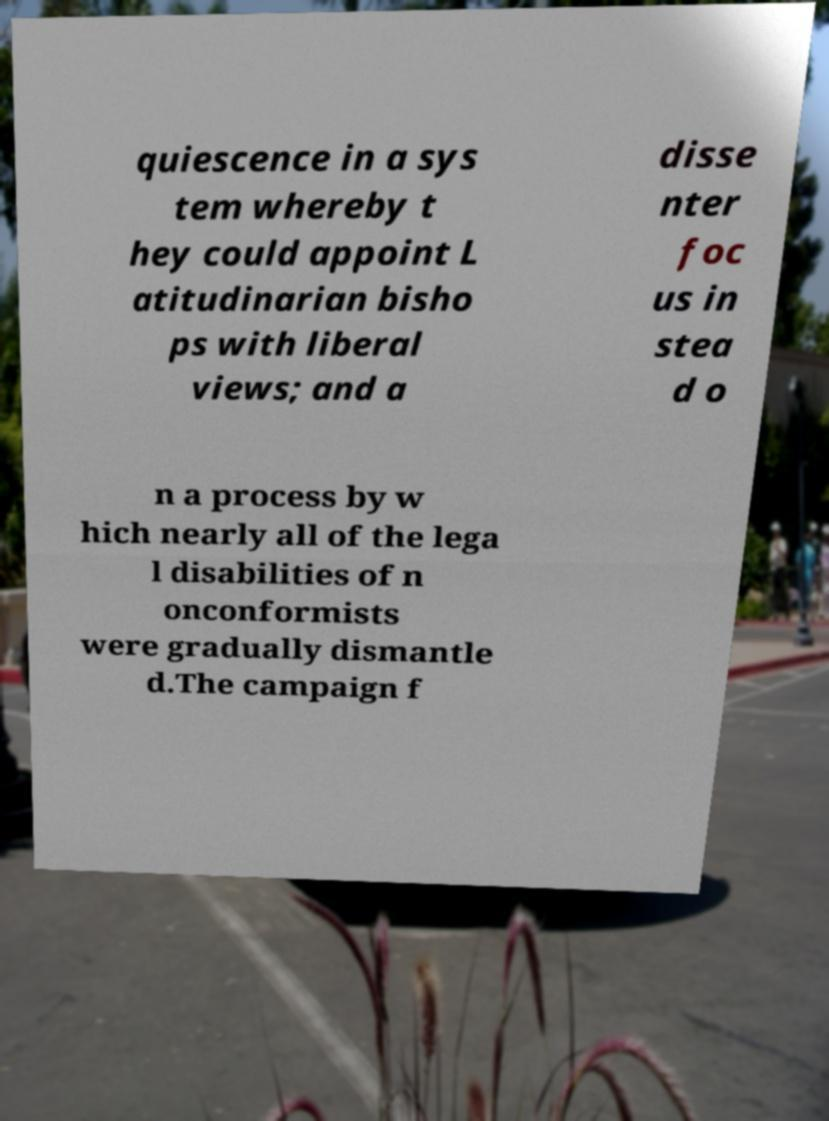What messages or text are displayed in this image? I need them in a readable, typed format. quiescence in a sys tem whereby t hey could appoint L atitudinarian bisho ps with liberal views; and a disse nter foc us in stea d o n a process by w hich nearly all of the lega l disabilities of n onconformists were gradually dismantle d.The campaign f 